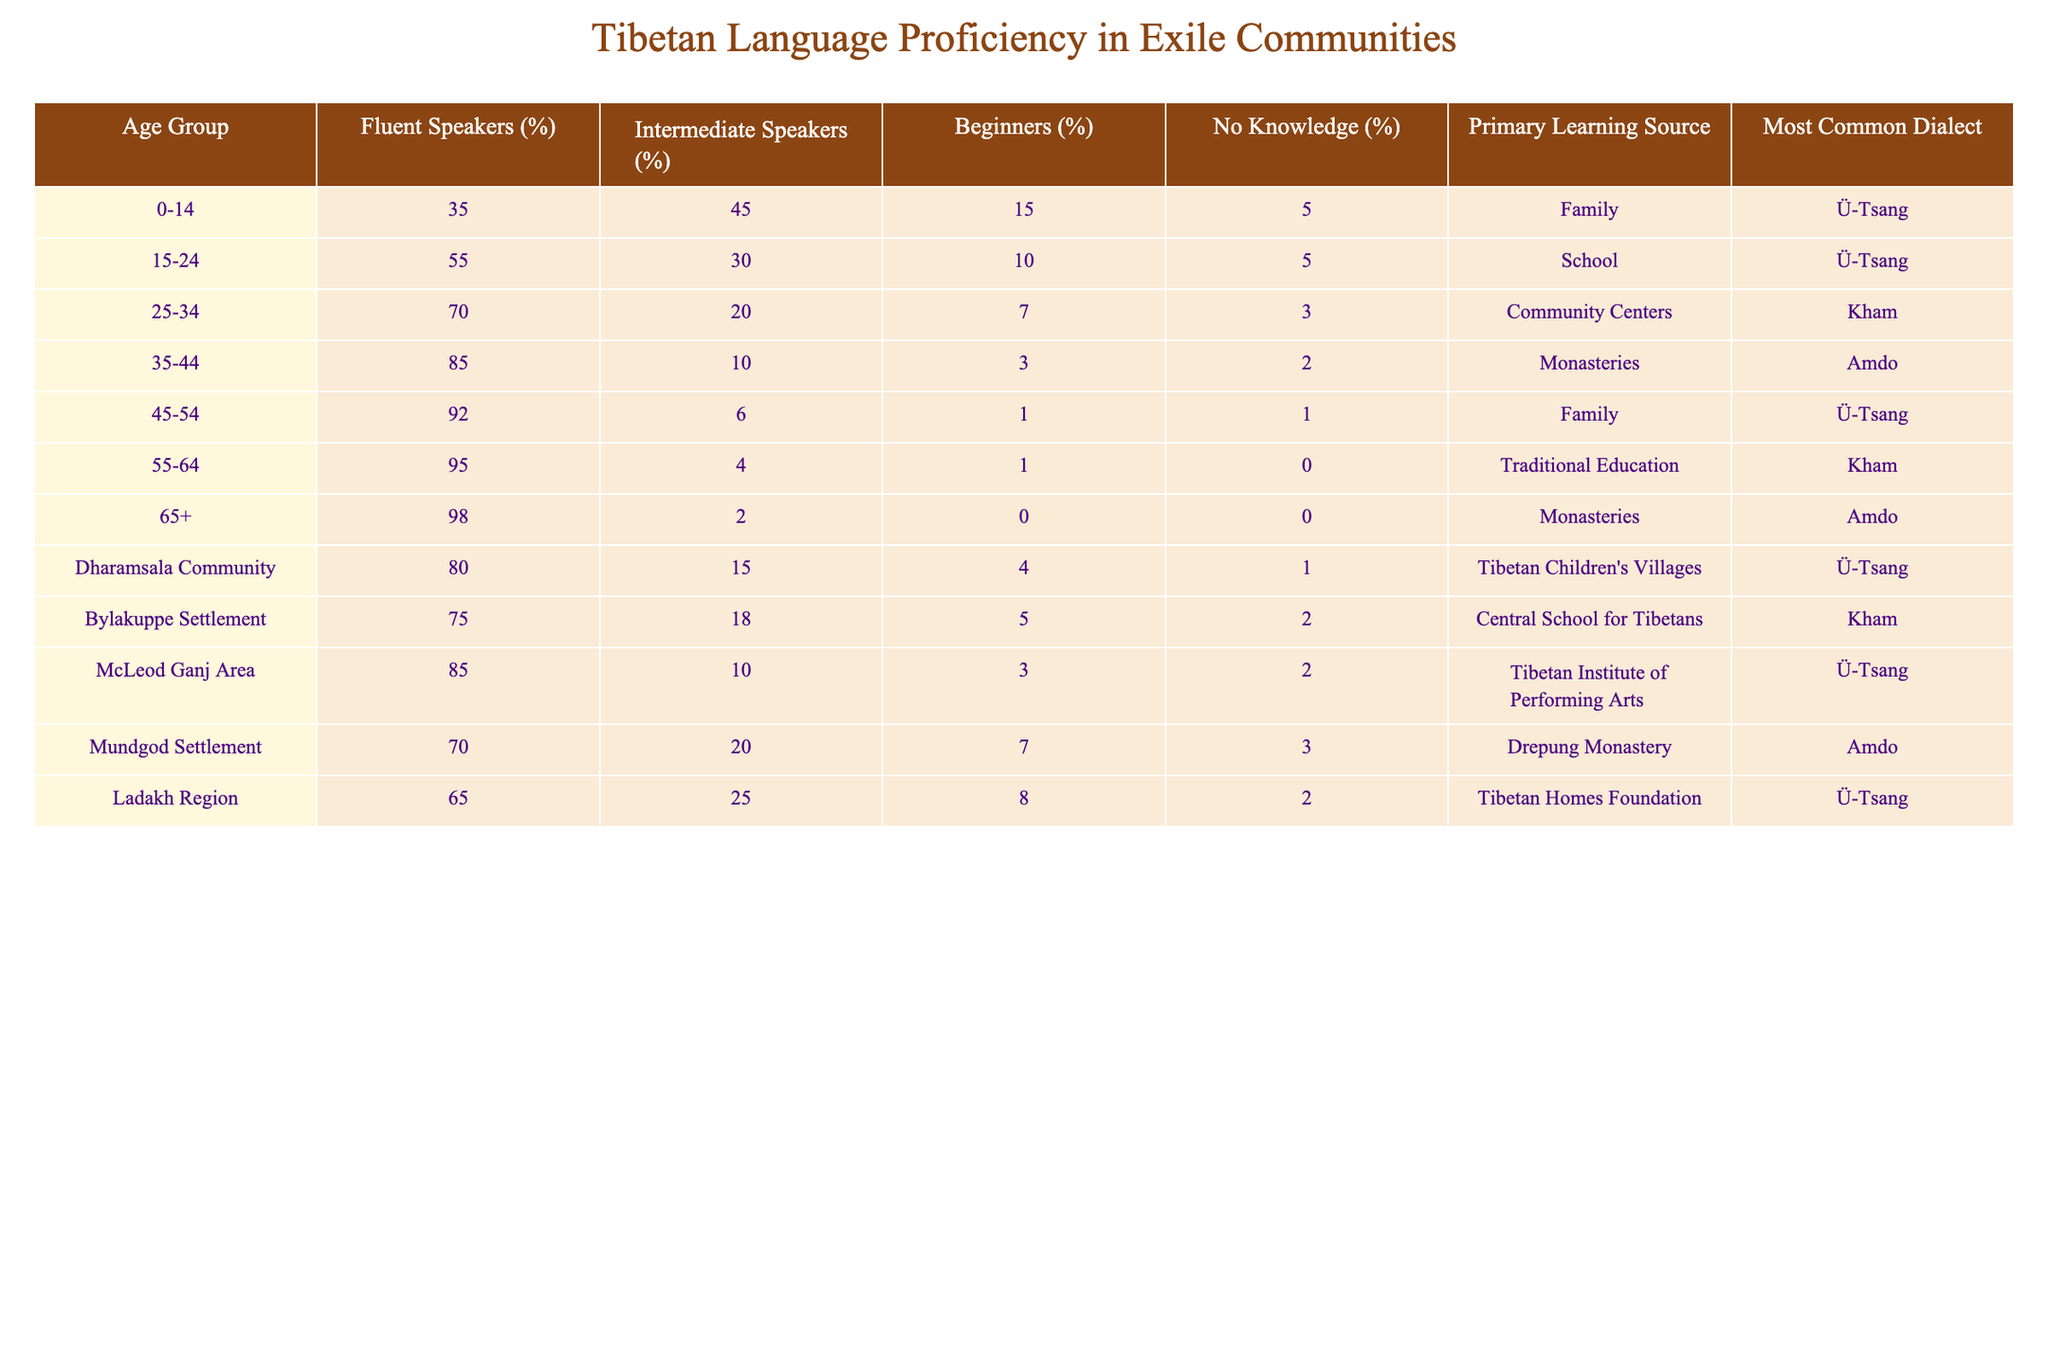What percentage of 55-64 age group members are fluent speakers? According to the table, the fluent speakers for the 55-64 age group is listed as 95%.
Answer: 95% Which age group has the highest percentage of beginners? The table shows that the age group 0-14 has 15% beginners, which is the highest compared to other age groups.
Answer: 0-14 In the Dharamsala Community, what is the percentage of speakers with no knowledge of Tibetan? The data indicates that in the Dharamsala Community, the percentage of no knowledge speakers is 1%.
Answer: 1% Is it true that the 25-34 age group has a higher percentage of intermediate speakers than the 15-24 age group? The table shows that 25-34 age group has 20% intermediate speakers, whereas the 15-24 age group has 30%. Thus, it is false that 25-34 has a higher percentage.
Answer: No What is the total percentage of fluent speakers among the 15-24 and 25-34 age groups combined? For the 15-24 age group, the fluent percentage is 55%. For the 25-34 age group, it is 70%. Adding these gives 55 + 70 = 125%.
Answer: 125% Which primary learning source is most common for the 45-54 age group? The table states that the primary learning source for the 45-54 age group is Family.
Answer: Family What is the average percentage of fluent speakers across all age groups? Adding all fluent speaker percentages: 35 + 55 + 70 + 85 + 92 + 95 + 98 + 80 + 75 + 85 + 70 + 65 = 1025. Dividing this by 12 (the total groups) gives an average of approximately 85.42%.
Answer: 85.42% How does the percentage of fluent speakers in the Bylakuppe Settlement compare to the McLeod Ganj Area? The table shows 75% fluent speakers in Bylakuppe and 85% in McLeod Ganj Area. Thus, McLeod Ganj Area has a higher percentage by 10%.
Answer: McLeod Ganj Area is higher by 10% What is the difference in the percentage of fluent speakers between the 35-44 age group and the 45-54 age group? The fluent percentage for 35-44 is 85% and for 45-54 is 92%. The difference is 92 - 85 = 7%.
Answer: 7% Which age group has the lowest percentage of speakers with no knowledge of Tibetan? The table shows that the 55-64 age group and the 65+ age group both have 0% speakers with no knowledge, which is the lowest possible.
Answer: 55-64 and 65+ age groups 